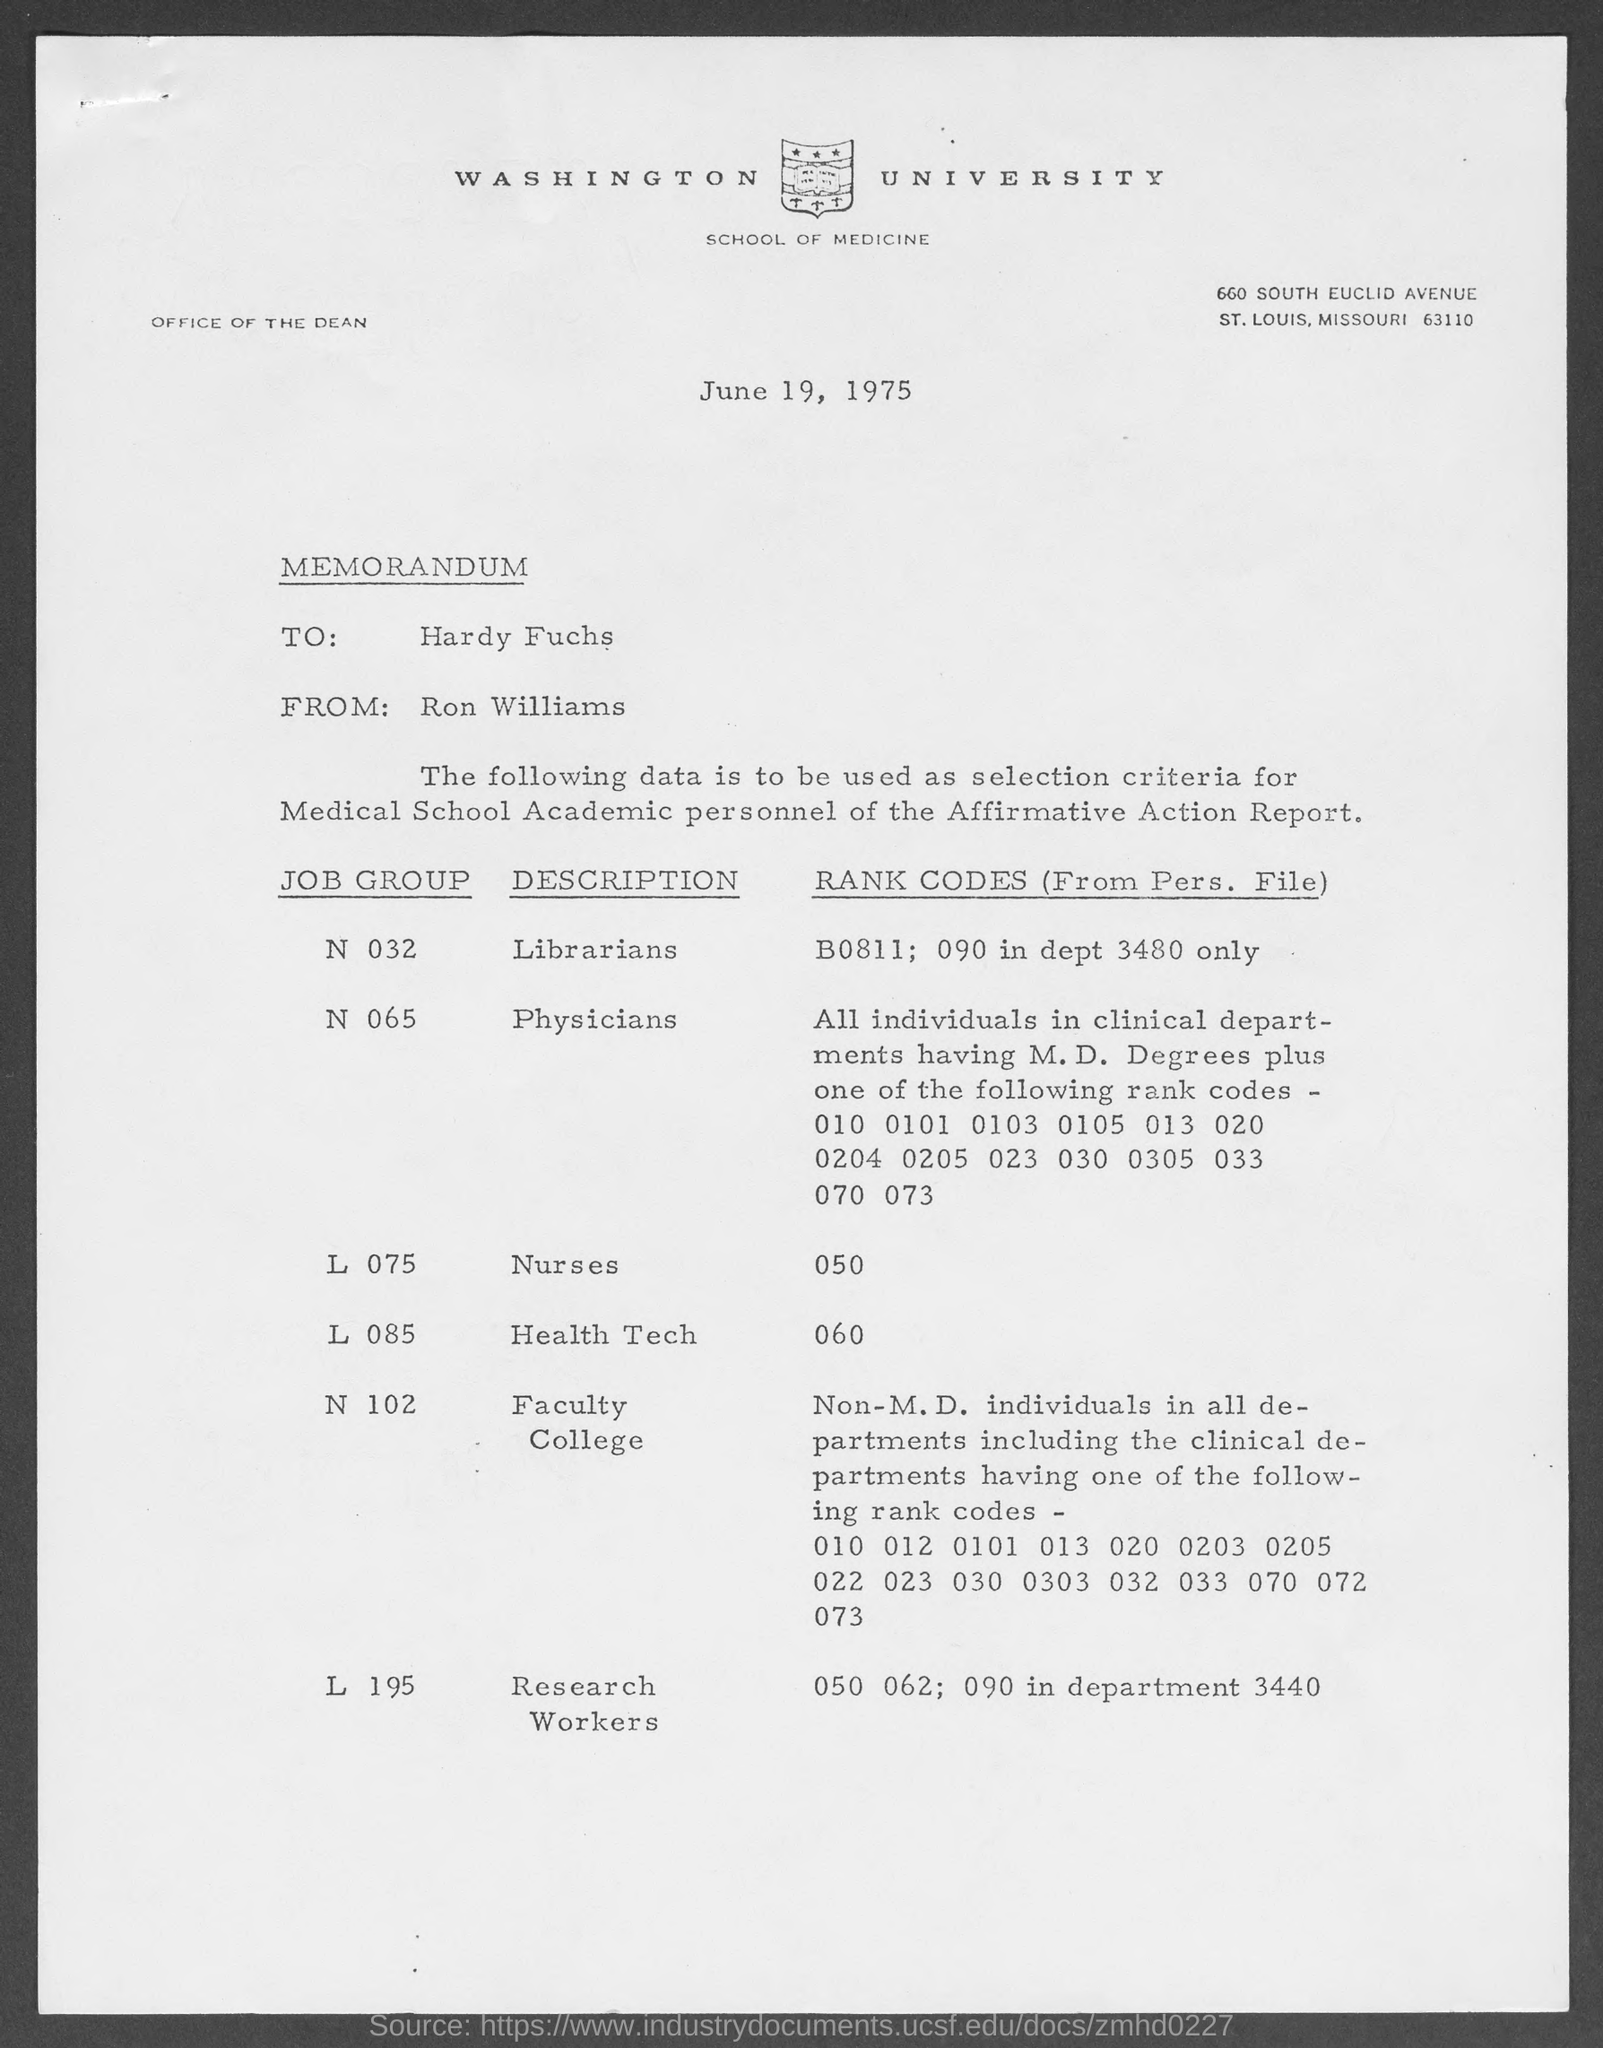Point out several critical features in this image. The memorandum is dated June 19, 1975. The name of the avenue where Washington University is located is 660 South Euclid Avenue. The memorandum is written to Hardy Fuchs. The memorandum is from Ron Williams. Physicians belong to the job group of professionals classified under code N065. 